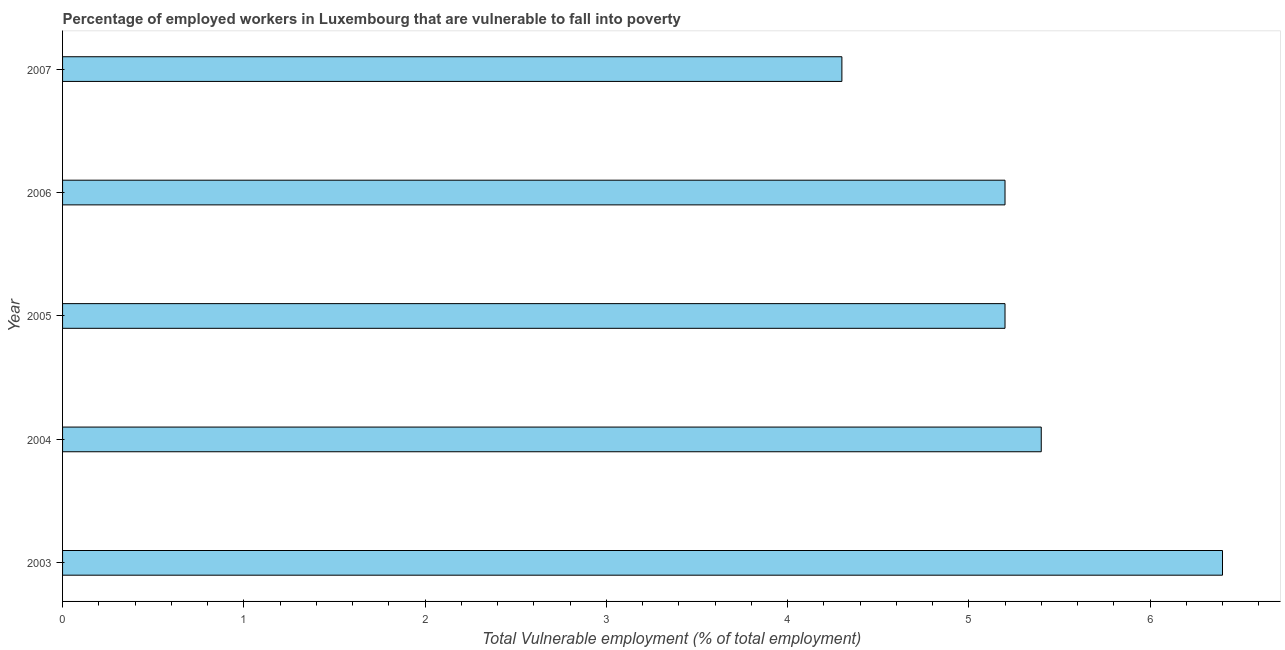Does the graph contain grids?
Give a very brief answer. No. What is the title of the graph?
Offer a very short reply. Percentage of employed workers in Luxembourg that are vulnerable to fall into poverty. What is the label or title of the X-axis?
Give a very brief answer. Total Vulnerable employment (% of total employment). What is the label or title of the Y-axis?
Keep it short and to the point. Year. What is the total vulnerable employment in 2006?
Give a very brief answer. 5.2. Across all years, what is the maximum total vulnerable employment?
Your response must be concise. 6.4. Across all years, what is the minimum total vulnerable employment?
Give a very brief answer. 4.3. In which year was the total vulnerable employment maximum?
Give a very brief answer. 2003. What is the sum of the total vulnerable employment?
Give a very brief answer. 26.5. What is the difference between the total vulnerable employment in 2003 and 2004?
Your answer should be very brief. 1. What is the median total vulnerable employment?
Ensure brevity in your answer.  5.2. What is the ratio of the total vulnerable employment in 2004 to that in 2005?
Provide a succinct answer. 1.04. Is the total vulnerable employment in 2004 less than that in 2007?
Offer a terse response. No. Is the difference between the total vulnerable employment in 2003 and 2006 greater than the difference between any two years?
Give a very brief answer. No. What is the difference between the highest and the second highest total vulnerable employment?
Provide a short and direct response. 1. Are all the bars in the graph horizontal?
Your answer should be very brief. Yes. How many years are there in the graph?
Offer a very short reply. 5. What is the Total Vulnerable employment (% of total employment) of 2003?
Offer a terse response. 6.4. What is the Total Vulnerable employment (% of total employment) of 2004?
Your answer should be compact. 5.4. What is the Total Vulnerable employment (% of total employment) in 2005?
Your answer should be very brief. 5.2. What is the Total Vulnerable employment (% of total employment) in 2006?
Keep it short and to the point. 5.2. What is the Total Vulnerable employment (% of total employment) in 2007?
Offer a terse response. 4.3. What is the difference between the Total Vulnerable employment (% of total employment) in 2003 and 2005?
Keep it short and to the point. 1.2. What is the difference between the Total Vulnerable employment (% of total employment) in 2003 and 2006?
Make the answer very short. 1.2. What is the difference between the Total Vulnerable employment (% of total employment) in 2003 and 2007?
Provide a short and direct response. 2.1. What is the difference between the Total Vulnerable employment (% of total employment) in 2004 and 2006?
Your response must be concise. 0.2. What is the difference between the Total Vulnerable employment (% of total employment) in 2004 and 2007?
Your answer should be compact. 1.1. What is the difference between the Total Vulnerable employment (% of total employment) in 2005 and 2006?
Provide a short and direct response. 0. What is the difference between the Total Vulnerable employment (% of total employment) in 2005 and 2007?
Offer a very short reply. 0.9. What is the ratio of the Total Vulnerable employment (% of total employment) in 2003 to that in 2004?
Make the answer very short. 1.19. What is the ratio of the Total Vulnerable employment (% of total employment) in 2003 to that in 2005?
Keep it short and to the point. 1.23. What is the ratio of the Total Vulnerable employment (% of total employment) in 2003 to that in 2006?
Give a very brief answer. 1.23. What is the ratio of the Total Vulnerable employment (% of total employment) in 2003 to that in 2007?
Keep it short and to the point. 1.49. What is the ratio of the Total Vulnerable employment (% of total employment) in 2004 to that in 2005?
Your answer should be very brief. 1.04. What is the ratio of the Total Vulnerable employment (% of total employment) in 2004 to that in 2006?
Make the answer very short. 1.04. What is the ratio of the Total Vulnerable employment (% of total employment) in 2004 to that in 2007?
Your answer should be very brief. 1.26. What is the ratio of the Total Vulnerable employment (% of total employment) in 2005 to that in 2006?
Keep it short and to the point. 1. What is the ratio of the Total Vulnerable employment (% of total employment) in 2005 to that in 2007?
Ensure brevity in your answer.  1.21. What is the ratio of the Total Vulnerable employment (% of total employment) in 2006 to that in 2007?
Your answer should be very brief. 1.21. 